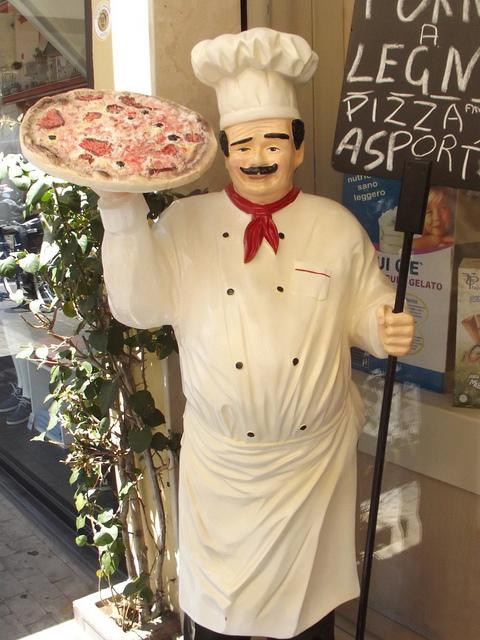What is the statue holding? Please explain your reasoning. pizza. The statue is of a chef holding a pan with pizza on it. 